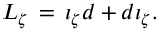<formula> <loc_0><loc_0><loc_500><loc_500>L _ { \zeta } \, = \, \iota _ { \zeta } d + { d \iota } _ { \zeta } .</formula> 